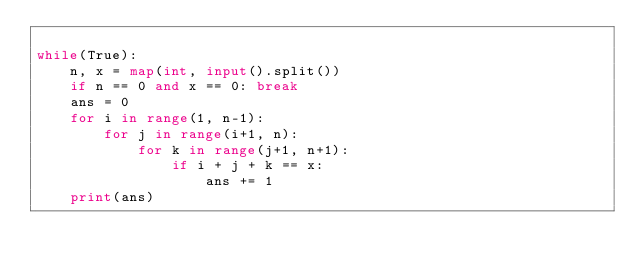Convert code to text. <code><loc_0><loc_0><loc_500><loc_500><_Python_>
while(True):
    n, x = map(int, input().split())
    if n == 0 and x == 0: break
    ans = 0
    for i in range(1, n-1):
        for j in range(i+1, n):
            for k in range(j+1, n+1):
                if i + j + k == x:
                    ans += 1
    print(ans)
</code> 